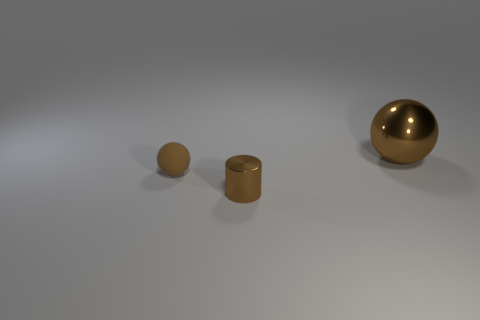What number of other objects are the same shape as the small brown rubber thing?
Keep it short and to the point. 1. Do the brown metal object that is on the left side of the large metallic object and the brown rubber object have the same shape?
Provide a short and direct response. No. Are there any big brown objects behind the small brown metallic object?
Provide a short and direct response. Yes. What number of big objects are either brown rubber balls or yellow balls?
Provide a short and direct response. 0. Is the tiny cylinder made of the same material as the large ball?
Keep it short and to the point. Yes. There is a shiny thing that is the same color as the small shiny cylinder; what is its size?
Offer a terse response. Large. Is there a large metallic thing that has the same color as the rubber ball?
Your response must be concise. Yes. There is a object that is made of the same material as the large sphere; what is its size?
Your response must be concise. Small. What shape is the brown metallic object left of the object on the right side of the tiny shiny cylinder that is in front of the large shiny sphere?
Your answer should be compact. Cylinder. There is another brown thing that is the same shape as the big brown thing; what is its size?
Offer a terse response. Small. 